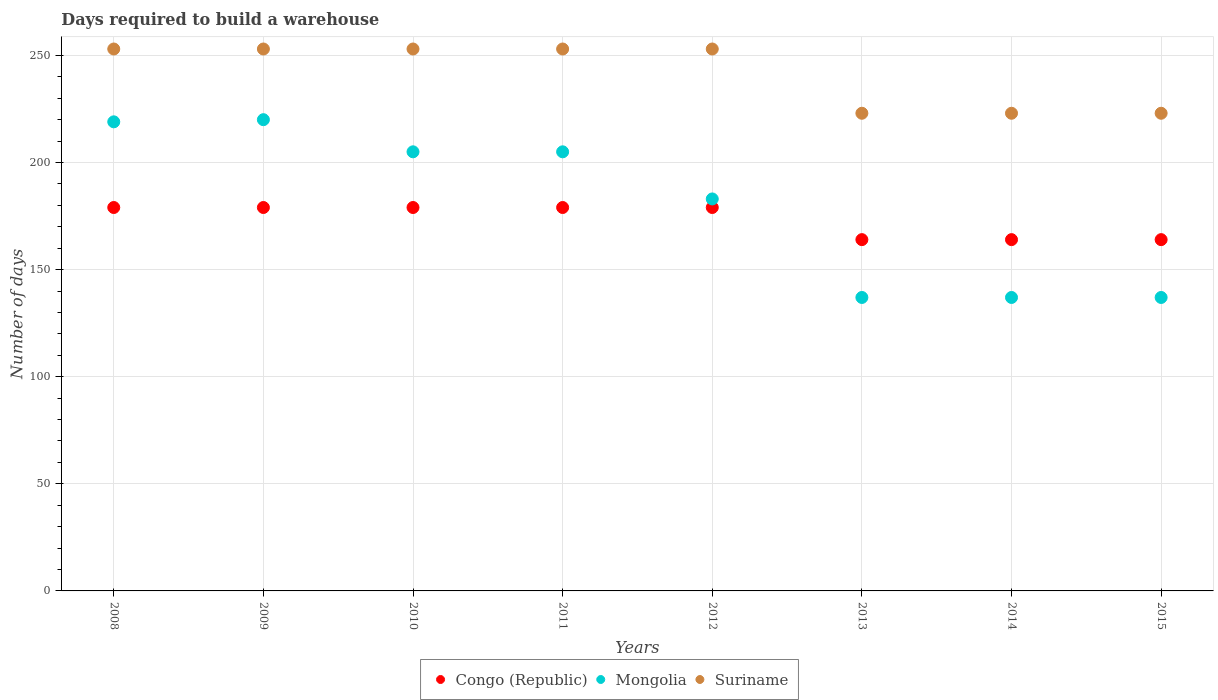What is the days required to build a warehouse in in Congo (Republic) in 2014?
Your response must be concise. 164. Across all years, what is the maximum days required to build a warehouse in in Mongolia?
Offer a very short reply. 220. Across all years, what is the minimum days required to build a warehouse in in Congo (Republic)?
Your answer should be compact. 164. In which year was the days required to build a warehouse in in Congo (Republic) minimum?
Your answer should be very brief. 2013. What is the total days required to build a warehouse in in Mongolia in the graph?
Provide a succinct answer. 1443. What is the difference between the days required to build a warehouse in in Congo (Republic) in 2008 and that in 2009?
Ensure brevity in your answer.  0. What is the difference between the days required to build a warehouse in in Suriname in 2015 and the days required to build a warehouse in in Mongolia in 2012?
Provide a short and direct response. 40. What is the average days required to build a warehouse in in Mongolia per year?
Give a very brief answer. 180.38. In the year 2008, what is the difference between the days required to build a warehouse in in Mongolia and days required to build a warehouse in in Congo (Republic)?
Provide a succinct answer. 40. In how many years, is the days required to build a warehouse in in Suriname greater than 80 days?
Keep it short and to the point. 8. What is the ratio of the days required to build a warehouse in in Congo (Republic) in 2010 to that in 2014?
Offer a very short reply. 1.09. Is the days required to build a warehouse in in Congo (Republic) in 2010 less than that in 2012?
Provide a succinct answer. No. Is the difference between the days required to build a warehouse in in Mongolia in 2011 and 2012 greater than the difference between the days required to build a warehouse in in Congo (Republic) in 2011 and 2012?
Make the answer very short. Yes. What is the difference between the highest and the lowest days required to build a warehouse in in Suriname?
Keep it short and to the point. 30. In how many years, is the days required to build a warehouse in in Suriname greater than the average days required to build a warehouse in in Suriname taken over all years?
Offer a terse response. 5. Does the days required to build a warehouse in in Mongolia monotonically increase over the years?
Offer a very short reply. No. How many years are there in the graph?
Keep it short and to the point. 8. What is the difference between two consecutive major ticks on the Y-axis?
Your answer should be very brief. 50. Where does the legend appear in the graph?
Ensure brevity in your answer.  Bottom center. How many legend labels are there?
Offer a very short reply. 3. What is the title of the graph?
Provide a succinct answer. Days required to build a warehouse. Does "Equatorial Guinea" appear as one of the legend labels in the graph?
Your answer should be compact. No. What is the label or title of the X-axis?
Give a very brief answer. Years. What is the label or title of the Y-axis?
Give a very brief answer. Number of days. What is the Number of days of Congo (Republic) in 2008?
Offer a very short reply. 179. What is the Number of days in Mongolia in 2008?
Ensure brevity in your answer.  219. What is the Number of days in Suriname in 2008?
Provide a succinct answer. 253. What is the Number of days of Congo (Republic) in 2009?
Your answer should be compact. 179. What is the Number of days in Mongolia in 2009?
Provide a succinct answer. 220. What is the Number of days in Suriname in 2009?
Make the answer very short. 253. What is the Number of days of Congo (Republic) in 2010?
Your answer should be very brief. 179. What is the Number of days of Mongolia in 2010?
Provide a succinct answer. 205. What is the Number of days of Suriname in 2010?
Offer a terse response. 253. What is the Number of days of Congo (Republic) in 2011?
Give a very brief answer. 179. What is the Number of days in Mongolia in 2011?
Your response must be concise. 205. What is the Number of days of Suriname in 2011?
Provide a succinct answer. 253. What is the Number of days in Congo (Republic) in 2012?
Provide a succinct answer. 179. What is the Number of days in Mongolia in 2012?
Offer a terse response. 183. What is the Number of days of Suriname in 2012?
Give a very brief answer. 253. What is the Number of days of Congo (Republic) in 2013?
Offer a terse response. 164. What is the Number of days in Mongolia in 2013?
Keep it short and to the point. 137. What is the Number of days of Suriname in 2013?
Keep it short and to the point. 223. What is the Number of days in Congo (Republic) in 2014?
Your answer should be compact. 164. What is the Number of days in Mongolia in 2014?
Give a very brief answer. 137. What is the Number of days in Suriname in 2014?
Offer a very short reply. 223. What is the Number of days in Congo (Republic) in 2015?
Make the answer very short. 164. What is the Number of days of Mongolia in 2015?
Offer a very short reply. 137. What is the Number of days in Suriname in 2015?
Your response must be concise. 223. Across all years, what is the maximum Number of days of Congo (Republic)?
Your answer should be very brief. 179. Across all years, what is the maximum Number of days of Mongolia?
Your answer should be compact. 220. Across all years, what is the maximum Number of days in Suriname?
Provide a short and direct response. 253. Across all years, what is the minimum Number of days of Congo (Republic)?
Your response must be concise. 164. Across all years, what is the minimum Number of days of Mongolia?
Give a very brief answer. 137. Across all years, what is the minimum Number of days in Suriname?
Provide a short and direct response. 223. What is the total Number of days of Congo (Republic) in the graph?
Keep it short and to the point. 1387. What is the total Number of days in Mongolia in the graph?
Give a very brief answer. 1443. What is the total Number of days in Suriname in the graph?
Offer a very short reply. 1934. What is the difference between the Number of days of Congo (Republic) in 2008 and that in 2009?
Your response must be concise. 0. What is the difference between the Number of days of Suriname in 2008 and that in 2010?
Make the answer very short. 0. What is the difference between the Number of days in Congo (Republic) in 2008 and that in 2011?
Provide a short and direct response. 0. What is the difference between the Number of days in Mongolia in 2008 and that in 2011?
Give a very brief answer. 14. What is the difference between the Number of days of Suriname in 2008 and that in 2011?
Your response must be concise. 0. What is the difference between the Number of days of Suriname in 2008 and that in 2012?
Make the answer very short. 0. What is the difference between the Number of days in Congo (Republic) in 2008 and that in 2013?
Give a very brief answer. 15. What is the difference between the Number of days in Mongolia in 2008 and that in 2013?
Your answer should be very brief. 82. What is the difference between the Number of days in Mongolia in 2008 and that in 2014?
Keep it short and to the point. 82. What is the difference between the Number of days in Congo (Republic) in 2008 and that in 2015?
Provide a succinct answer. 15. What is the difference between the Number of days of Mongolia in 2009 and that in 2011?
Provide a short and direct response. 15. What is the difference between the Number of days of Suriname in 2009 and that in 2011?
Offer a terse response. 0. What is the difference between the Number of days in Congo (Republic) in 2009 and that in 2012?
Make the answer very short. 0. What is the difference between the Number of days in Suriname in 2009 and that in 2012?
Offer a very short reply. 0. What is the difference between the Number of days in Suriname in 2009 and that in 2013?
Your answer should be compact. 30. What is the difference between the Number of days of Congo (Republic) in 2009 and that in 2014?
Your answer should be very brief. 15. What is the difference between the Number of days of Congo (Republic) in 2009 and that in 2015?
Your response must be concise. 15. What is the difference between the Number of days in Mongolia in 2009 and that in 2015?
Offer a very short reply. 83. What is the difference between the Number of days of Suriname in 2009 and that in 2015?
Provide a short and direct response. 30. What is the difference between the Number of days of Suriname in 2010 and that in 2011?
Offer a terse response. 0. What is the difference between the Number of days of Congo (Republic) in 2010 and that in 2012?
Give a very brief answer. 0. What is the difference between the Number of days in Suriname in 2010 and that in 2013?
Your answer should be compact. 30. What is the difference between the Number of days of Suriname in 2010 and that in 2014?
Keep it short and to the point. 30. What is the difference between the Number of days in Mongolia in 2010 and that in 2015?
Give a very brief answer. 68. What is the difference between the Number of days in Suriname in 2010 and that in 2015?
Make the answer very short. 30. What is the difference between the Number of days in Congo (Republic) in 2011 and that in 2012?
Provide a short and direct response. 0. What is the difference between the Number of days of Mongolia in 2011 and that in 2012?
Offer a terse response. 22. What is the difference between the Number of days in Suriname in 2011 and that in 2012?
Give a very brief answer. 0. What is the difference between the Number of days in Congo (Republic) in 2011 and that in 2013?
Offer a terse response. 15. What is the difference between the Number of days of Suriname in 2011 and that in 2013?
Provide a short and direct response. 30. What is the difference between the Number of days in Congo (Republic) in 2011 and that in 2015?
Your answer should be very brief. 15. What is the difference between the Number of days of Mongolia in 2011 and that in 2015?
Provide a succinct answer. 68. What is the difference between the Number of days of Congo (Republic) in 2012 and that in 2013?
Make the answer very short. 15. What is the difference between the Number of days in Mongolia in 2012 and that in 2013?
Provide a succinct answer. 46. What is the difference between the Number of days in Congo (Republic) in 2012 and that in 2014?
Provide a short and direct response. 15. What is the difference between the Number of days of Congo (Republic) in 2012 and that in 2015?
Keep it short and to the point. 15. What is the difference between the Number of days in Suriname in 2012 and that in 2015?
Your response must be concise. 30. What is the difference between the Number of days of Congo (Republic) in 2013 and that in 2014?
Keep it short and to the point. 0. What is the difference between the Number of days in Mongolia in 2013 and that in 2014?
Provide a short and direct response. 0. What is the difference between the Number of days in Suriname in 2013 and that in 2014?
Offer a very short reply. 0. What is the difference between the Number of days of Congo (Republic) in 2013 and that in 2015?
Offer a very short reply. 0. What is the difference between the Number of days in Congo (Republic) in 2014 and that in 2015?
Keep it short and to the point. 0. What is the difference between the Number of days of Mongolia in 2014 and that in 2015?
Keep it short and to the point. 0. What is the difference between the Number of days in Congo (Republic) in 2008 and the Number of days in Mongolia in 2009?
Offer a very short reply. -41. What is the difference between the Number of days in Congo (Republic) in 2008 and the Number of days in Suriname in 2009?
Keep it short and to the point. -74. What is the difference between the Number of days of Mongolia in 2008 and the Number of days of Suriname in 2009?
Your answer should be very brief. -34. What is the difference between the Number of days of Congo (Republic) in 2008 and the Number of days of Mongolia in 2010?
Your answer should be very brief. -26. What is the difference between the Number of days of Congo (Republic) in 2008 and the Number of days of Suriname in 2010?
Keep it short and to the point. -74. What is the difference between the Number of days of Mongolia in 2008 and the Number of days of Suriname in 2010?
Offer a terse response. -34. What is the difference between the Number of days of Congo (Republic) in 2008 and the Number of days of Suriname in 2011?
Make the answer very short. -74. What is the difference between the Number of days in Mongolia in 2008 and the Number of days in Suriname in 2011?
Give a very brief answer. -34. What is the difference between the Number of days of Congo (Republic) in 2008 and the Number of days of Mongolia in 2012?
Give a very brief answer. -4. What is the difference between the Number of days in Congo (Republic) in 2008 and the Number of days in Suriname in 2012?
Offer a terse response. -74. What is the difference between the Number of days in Mongolia in 2008 and the Number of days in Suriname in 2012?
Provide a succinct answer. -34. What is the difference between the Number of days of Congo (Republic) in 2008 and the Number of days of Mongolia in 2013?
Keep it short and to the point. 42. What is the difference between the Number of days of Congo (Republic) in 2008 and the Number of days of Suriname in 2013?
Your answer should be very brief. -44. What is the difference between the Number of days in Mongolia in 2008 and the Number of days in Suriname in 2013?
Give a very brief answer. -4. What is the difference between the Number of days in Congo (Republic) in 2008 and the Number of days in Mongolia in 2014?
Offer a very short reply. 42. What is the difference between the Number of days in Congo (Republic) in 2008 and the Number of days in Suriname in 2014?
Your response must be concise. -44. What is the difference between the Number of days in Congo (Republic) in 2008 and the Number of days in Mongolia in 2015?
Your answer should be compact. 42. What is the difference between the Number of days in Congo (Republic) in 2008 and the Number of days in Suriname in 2015?
Provide a short and direct response. -44. What is the difference between the Number of days in Mongolia in 2008 and the Number of days in Suriname in 2015?
Make the answer very short. -4. What is the difference between the Number of days of Congo (Republic) in 2009 and the Number of days of Suriname in 2010?
Offer a terse response. -74. What is the difference between the Number of days in Mongolia in 2009 and the Number of days in Suriname in 2010?
Offer a very short reply. -33. What is the difference between the Number of days in Congo (Republic) in 2009 and the Number of days in Suriname in 2011?
Provide a short and direct response. -74. What is the difference between the Number of days of Mongolia in 2009 and the Number of days of Suriname in 2011?
Your answer should be compact. -33. What is the difference between the Number of days in Congo (Republic) in 2009 and the Number of days in Mongolia in 2012?
Provide a succinct answer. -4. What is the difference between the Number of days in Congo (Republic) in 2009 and the Number of days in Suriname in 2012?
Your answer should be compact. -74. What is the difference between the Number of days in Mongolia in 2009 and the Number of days in Suriname in 2012?
Your response must be concise. -33. What is the difference between the Number of days of Congo (Republic) in 2009 and the Number of days of Suriname in 2013?
Ensure brevity in your answer.  -44. What is the difference between the Number of days of Congo (Republic) in 2009 and the Number of days of Suriname in 2014?
Provide a succinct answer. -44. What is the difference between the Number of days of Congo (Republic) in 2009 and the Number of days of Suriname in 2015?
Your answer should be compact. -44. What is the difference between the Number of days of Congo (Republic) in 2010 and the Number of days of Suriname in 2011?
Give a very brief answer. -74. What is the difference between the Number of days in Mongolia in 2010 and the Number of days in Suriname in 2011?
Make the answer very short. -48. What is the difference between the Number of days of Congo (Republic) in 2010 and the Number of days of Suriname in 2012?
Make the answer very short. -74. What is the difference between the Number of days in Mongolia in 2010 and the Number of days in Suriname in 2012?
Keep it short and to the point. -48. What is the difference between the Number of days in Congo (Republic) in 2010 and the Number of days in Mongolia in 2013?
Keep it short and to the point. 42. What is the difference between the Number of days in Congo (Republic) in 2010 and the Number of days in Suriname in 2013?
Offer a very short reply. -44. What is the difference between the Number of days of Congo (Republic) in 2010 and the Number of days of Mongolia in 2014?
Ensure brevity in your answer.  42. What is the difference between the Number of days in Congo (Republic) in 2010 and the Number of days in Suriname in 2014?
Give a very brief answer. -44. What is the difference between the Number of days of Mongolia in 2010 and the Number of days of Suriname in 2014?
Give a very brief answer. -18. What is the difference between the Number of days of Congo (Republic) in 2010 and the Number of days of Suriname in 2015?
Your answer should be very brief. -44. What is the difference between the Number of days of Mongolia in 2010 and the Number of days of Suriname in 2015?
Your answer should be compact. -18. What is the difference between the Number of days of Congo (Republic) in 2011 and the Number of days of Suriname in 2012?
Give a very brief answer. -74. What is the difference between the Number of days in Mongolia in 2011 and the Number of days in Suriname in 2012?
Your answer should be very brief. -48. What is the difference between the Number of days in Congo (Republic) in 2011 and the Number of days in Suriname in 2013?
Ensure brevity in your answer.  -44. What is the difference between the Number of days in Congo (Republic) in 2011 and the Number of days in Suriname in 2014?
Provide a short and direct response. -44. What is the difference between the Number of days in Mongolia in 2011 and the Number of days in Suriname in 2014?
Ensure brevity in your answer.  -18. What is the difference between the Number of days in Congo (Republic) in 2011 and the Number of days in Suriname in 2015?
Ensure brevity in your answer.  -44. What is the difference between the Number of days of Congo (Republic) in 2012 and the Number of days of Suriname in 2013?
Keep it short and to the point. -44. What is the difference between the Number of days in Mongolia in 2012 and the Number of days in Suriname in 2013?
Your answer should be very brief. -40. What is the difference between the Number of days of Congo (Republic) in 2012 and the Number of days of Mongolia in 2014?
Provide a succinct answer. 42. What is the difference between the Number of days in Congo (Republic) in 2012 and the Number of days in Suriname in 2014?
Provide a short and direct response. -44. What is the difference between the Number of days in Congo (Republic) in 2012 and the Number of days in Suriname in 2015?
Your response must be concise. -44. What is the difference between the Number of days of Congo (Republic) in 2013 and the Number of days of Mongolia in 2014?
Offer a very short reply. 27. What is the difference between the Number of days in Congo (Republic) in 2013 and the Number of days in Suriname in 2014?
Offer a terse response. -59. What is the difference between the Number of days of Mongolia in 2013 and the Number of days of Suriname in 2014?
Ensure brevity in your answer.  -86. What is the difference between the Number of days in Congo (Republic) in 2013 and the Number of days in Mongolia in 2015?
Your response must be concise. 27. What is the difference between the Number of days of Congo (Republic) in 2013 and the Number of days of Suriname in 2015?
Provide a succinct answer. -59. What is the difference between the Number of days in Mongolia in 2013 and the Number of days in Suriname in 2015?
Your response must be concise. -86. What is the difference between the Number of days of Congo (Republic) in 2014 and the Number of days of Mongolia in 2015?
Your answer should be compact. 27. What is the difference between the Number of days in Congo (Republic) in 2014 and the Number of days in Suriname in 2015?
Keep it short and to the point. -59. What is the difference between the Number of days of Mongolia in 2014 and the Number of days of Suriname in 2015?
Ensure brevity in your answer.  -86. What is the average Number of days in Congo (Republic) per year?
Make the answer very short. 173.38. What is the average Number of days in Mongolia per year?
Make the answer very short. 180.38. What is the average Number of days of Suriname per year?
Your response must be concise. 241.75. In the year 2008, what is the difference between the Number of days of Congo (Republic) and Number of days of Suriname?
Provide a succinct answer. -74. In the year 2008, what is the difference between the Number of days in Mongolia and Number of days in Suriname?
Provide a short and direct response. -34. In the year 2009, what is the difference between the Number of days in Congo (Republic) and Number of days in Mongolia?
Offer a terse response. -41. In the year 2009, what is the difference between the Number of days in Congo (Republic) and Number of days in Suriname?
Ensure brevity in your answer.  -74. In the year 2009, what is the difference between the Number of days in Mongolia and Number of days in Suriname?
Your answer should be compact. -33. In the year 2010, what is the difference between the Number of days of Congo (Republic) and Number of days of Mongolia?
Make the answer very short. -26. In the year 2010, what is the difference between the Number of days in Congo (Republic) and Number of days in Suriname?
Your answer should be compact. -74. In the year 2010, what is the difference between the Number of days of Mongolia and Number of days of Suriname?
Your answer should be compact. -48. In the year 2011, what is the difference between the Number of days of Congo (Republic) and Number of days of Suriname?
Make the answer very short. -74. In the year 2011, what is the difference between the Number of days of Mongolia and Number of days of Suriname?
Your answer should be very brief. -48. In the year 2012, what is the difference between the Number of days of Congo (Republic) and Number of days of Suriname?
Provide a succinct answer. -74. In the year 2012, what is the difference between the Number of days of Mongolia and Number of days of Suriname?
Your answer should be compact. -70. In the year 2013, what is the difference between the Number of days in Congo (Republic) and Number of days in Mongolia?
Keep it short and to the point. 27. In the year 2013, what is the difference between the Number of days of Congo (Republic) and Number of days of Suriname?
Provide a short and direct response. -59. In the year 2013, what is the difference between the Number of days of Mongolia and Number of days of Suriname?
Offer a terse response. -86. In the year 2014, what is the difference between the Number of days of Congo (Republic) and Number of days of Mongolia?
Your answer should be very brief. 27. In the year 2014, what is the difference between the Number of days in Congo (Republic) and Number of days in Suriname?
Provide a short and direct response. -59. In the year 2014, what is the difference between the Number of days in Mongolia and Number of days in Suriname?
Offer a terse response. -86. In the year 2015, what is the difference between the Number of days in Congo (Republic) and Number of days in Suriname?
Make the answer very short. -59. In the year 2015, what is the difference between the Number of days of Mongolia and Number of days of Suriname?
Your answer should be very brief. -86. What is the ratio of the Number of days of Suriname in 2008 to that in 2009?
Offer a very short reply. 1. What is the ratio of the Number of days of Congo (Republic) in 2008 to that in 2010?
Provide a succinct answer. 1. What is the ratio of the Number of days in Mongolia in 2008 to that in 2010?
Give a very brief answer. 1.07. What is the ratio of the Number of days of Suriname in 2008 to that in 2010?
Provide a short and direct response. 1. What is the ratio of the Number of days of Mongolia in 2008 to that in 2011?
Your answer should be very brief. 1.07. What is the ratio of the Number of days in Mongolia in 2008 to that in 2012?
Ensure brevity in your answer.  1.2. What is the ratio of the Number of days in Suriname in 2008 to that in 2012?
Your response must be concise. 1. What is the ratio of the Number of days of Congo (Republic) in 2008 to that in 2013?
Make the answer very short. 1.09. What is the ratio of the Number of days of Mongolia in 2008 to that in 2013?
Your response must be concise. 1.6. What is the ratio of the Number of days in Suriname in 2008 to that in 2013?
Give a very brief answer. 1.13. What is the ratio of the Number of days in Congo (Republic) in 2008 to that in 2014?
Provide a succinct answer. 1.09. What is the ratio of the Number of days in Mongolia in 2008 to that in 2014?
Make the answer very short. 1.6. What is the ratio of the Number of days in Suriname in 2008 to that in 2014?
Offer a terse response. 1.13. What is the ratio of the Number of days of Congo (Republic) in 2008 to that in 2015?
Offer a very short reply. 1.09. What is the ratio of the Number of days in Mongolia in 2008 to that in 2015?
Your response must be concise. 1.6. What is the ratio of the Number of days of Suriname in 2008 to that in 2015?
Make the answer very short. 1.13. What is the ratio of the Number of days of Mongolia in 2009 to that in 2010?
Offer a very short reply. 1.07. What is the ratio of the Number of days in Mongolia in 2009 to that in 2011?
Your answer should be very brief. 1.07. What is the ratio of the Number of days in Mongolia in 2009 to that in 2012?
Keep it short and to the point. 1.2. What is the ratio of the Number of days in Suriname in 2009 to that in 2012?
Your response must be concise. 1. What is the ratio of the Number of days in Congo (Republic) in 2009 to that in 2013?
Keep it short and to the point. 1.09. What is the ratio of the Number of days in Mongolia in 2009 to that in 2013?
Make the answer very short. 1.61. What is the ratio of the Number of days of Suriname in 2009 to that in 2013?
Offer a very short reply. 1.13. What is the ratio of the Number of days of Congo (Republic) in 2009 to that in 2014?
Keep it short and to the point. 1.09. What is the ratio of the Number of days in Mongolia in 2009 to that in 2014?
Your response must be concise. 1.61. What is the ratio of the Number of days in Suriname in 2009 to that in 2014?
Your answer should be very brief. 1.13. What is the ratio of the Number of days of Congo (Republic) in 2009 to that in 2015?
Give a very brief answer. 1.09. What is the ratio of the Number of days of Mongolia in 2009 to that in 2015?
Keep it short and to the point. 1.61. What is the ratio of the Number of days in Suriname in 2009 to that in 2015?
Your answer should be compact. 1.13. What is the ratio of the Number of days in Mongolia in 2010 to that in 2011?
Your answer should be compact. 1. What is the ratio of the Number of days of Congo (Republic) in 2010 to that in 2012?
Offer a very short reply. 1. What is the ratio of the Number of days of Mongolia in 2010 to that in 2012?
Provide a succinct answer. 1.12. What is the ratio of the Number of days in Suriname in 2010 to that in 2012?
Offer a very short reply. 1. What is the ratio of the Number of days in Congo (Republic) in 2010 to that in 2013?
Your answer should be very brief. 1.09. What is the ratio of the Number of days of Mongolia in 2010 to that in 2013?
Give a very brief answer. 1.5. What is the ratio of the Number of days of Suriname in 2010 to that in 2013?
Your answer should be compact. 1.13. What is the ratio of the Number of days in Congo (Republic) in 2010 to that in 2014?
Your answer should be compact. 1.09. What is the ratio of the Number of days of Mongolia in 2010 to that in 2014?
Your response must be concise. 1.5. What is the ratio of the Number of days in Suriname in 2010 to that in 2014?
Offer a very short reply. 1.13. What is the ratio of the Number of days in Congo (Republic) in 2010 to that in 2015?
Offer a very short reply. 1.09. What is the ratio of the Number of days in Mongolia in 2010 to that in 2015?
Your answer should be very brief. 1.5. What is the ratio of the Number of days in Suriname in 2010 to that in 2015?
Your answer should be compact. 1.13. What is the ratio of the Number of days of Congo (Republic) in 2011 to that in 2012?
Your answer should be compact. 1. What is the ratio of the Number of days of Mongolia in 2011 to that in 2012?
Your answer should be compact. 1.12. What is the ratio of the Number of days in Suriname in 2011 to that in 2012?
Give a very brief answer. 1. What is the ratio of the Number of days in Congo (Republic) in 2011 to that in 2013?
Your answer should be very brief. 1.09. What is the ratio of the Number of days of Mongolia in 2011 to that in 2013?
Provide a short and direct response. 1.5. What is the ratio of the Number of days of Suriname in 2011 to that in 2013?
Your answer should be very brief. 1.13. What is the ratio of the Number of days in Congo (Republic) in 2011 to that in 2014?
Provide a short and direct response. 1.09. What is the ratio of the Number of days of Mongolia in 2011 to that in 2014?
Offer a terse response. 1.5. What is the ratio of the Number of days of Suriname in 2011 to that in 2014?
Provide a short and direct response. 1.13. What is the ratio of the Number of days of Congo (Republic) in 2011 to that in 2015?
Keep it short and to the point. 1.09. What is the ratio of the Number of days in Mongolia in 2011 to that in 2015?
Provide a short and direct response. 1.5. What is the ratio of the Number of days of Suriname in 2011 to that in 2015?
Provide a succinct answer. 1.13. What is the ratio of the Number of days of Congo (Republic) in 2012 to that in 2013?
Provide a short and direct response. 1.09. What is the ratio of the Number of days of Mongolia in 2012 to that in 2013?
Offer a terse response. 1.34. What is the ratio of the Number of days of Suriname in 2012 to that in 2013?
Offer a terse response. 1.13. What is the ratio of the Number of days in Congo (Republic) in 2012 to that in 2014?
Offer a very short reply. 1.09. What is the ratio of the Number of days of Mongolia in 2012 to that in 2014?
Your answer should be compact. 1.34. What is the ratio of the Number of days of Suriname in 2012 to that in 2014?
Offer a very short reply. 1.13. What is the ratio of the Number of days of Congo (Republic) in 2012 to that in 2015?
Offer a very short reply. 1.09. What is the ratio of the Number of days of Mongolia in 2012 to that in 2015?
Ensure brevity in your answer.  1.34. What is the ratio of the Number of days of Suriname in 2012 to that in 2015?
Make the answer very short. 1.13. What is the ratio of the Number of days in Congo (Republic) in 2013 to that in 2014?
Offer a very short reply. 1. What is the ratio of the Number of days in Mongolia in 2013 to that in 2014?
Your answer should be compact. 1. What is the ratio of the Number of days of Suriname in 2013 to that in 2014?
Make the answer very short. 1. What is the ratio of the Number of days in Suriname in 2013 to that in 2015?
Keep it short and to the point. 1. 